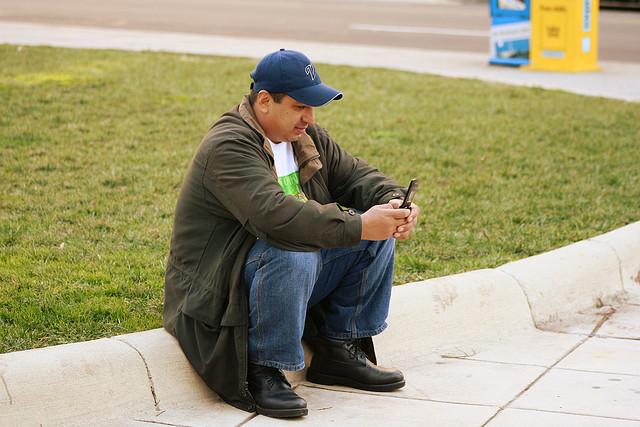Is the man dressed as a businessman?
Keep it brief. No. What is the sidewalk divided into?
Quick response, please. Squares. Is this an old picture?
Write a very short answer. No. How many people are there?
Write a very short answer. 1. Are there weeds in the grass?
Quick response, please. No. What is in the yellow box on the curb?
Give a very brief answer. Newspapers. What kind of hat is he wearing?
Concise answer only. Baseball. Is the guy wearing a tailored suit?
Quick response, please. No. Do you think the guy is having a serious phone conversation?
Be succinct. No. 